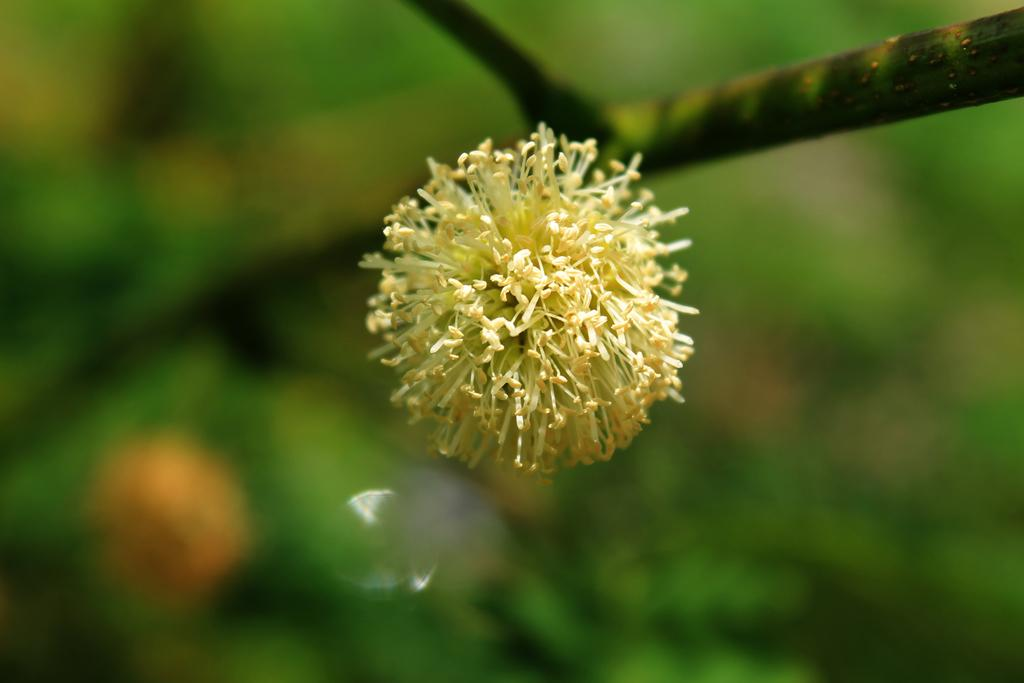What is the main subject of the image? There is a flower in the image. Where is the flower located in the image? The flower is in the center of the image. What story does the flower tell about the need for winter clothing in the image? There is no story or reference to winter clothing in the image; it only features a flower in the center. 